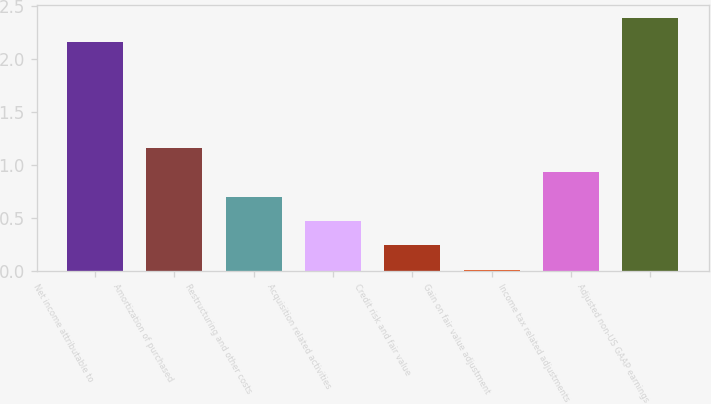Convert chart. <chart><loc_0><loc_0><loc_500><loc_500><bar_chart><fcel>Net income attributable to<fcel>Amortization of purchased<fcel>Restructuring and other costs<fcel>Acquisition related activities<fcel>Credit risk and fair value<fcel>Gain on fair value adjustment<fcel>Income tax related adjustments<fcel>Adjusted non-US GAAP earnings<nl><fcel>2.16<fcel>1.16<fcel>0.7<fcel>0.47<fcel>0.24<fcel>0.01<fcel>0.93<fcel>2.39<nl></chart> 